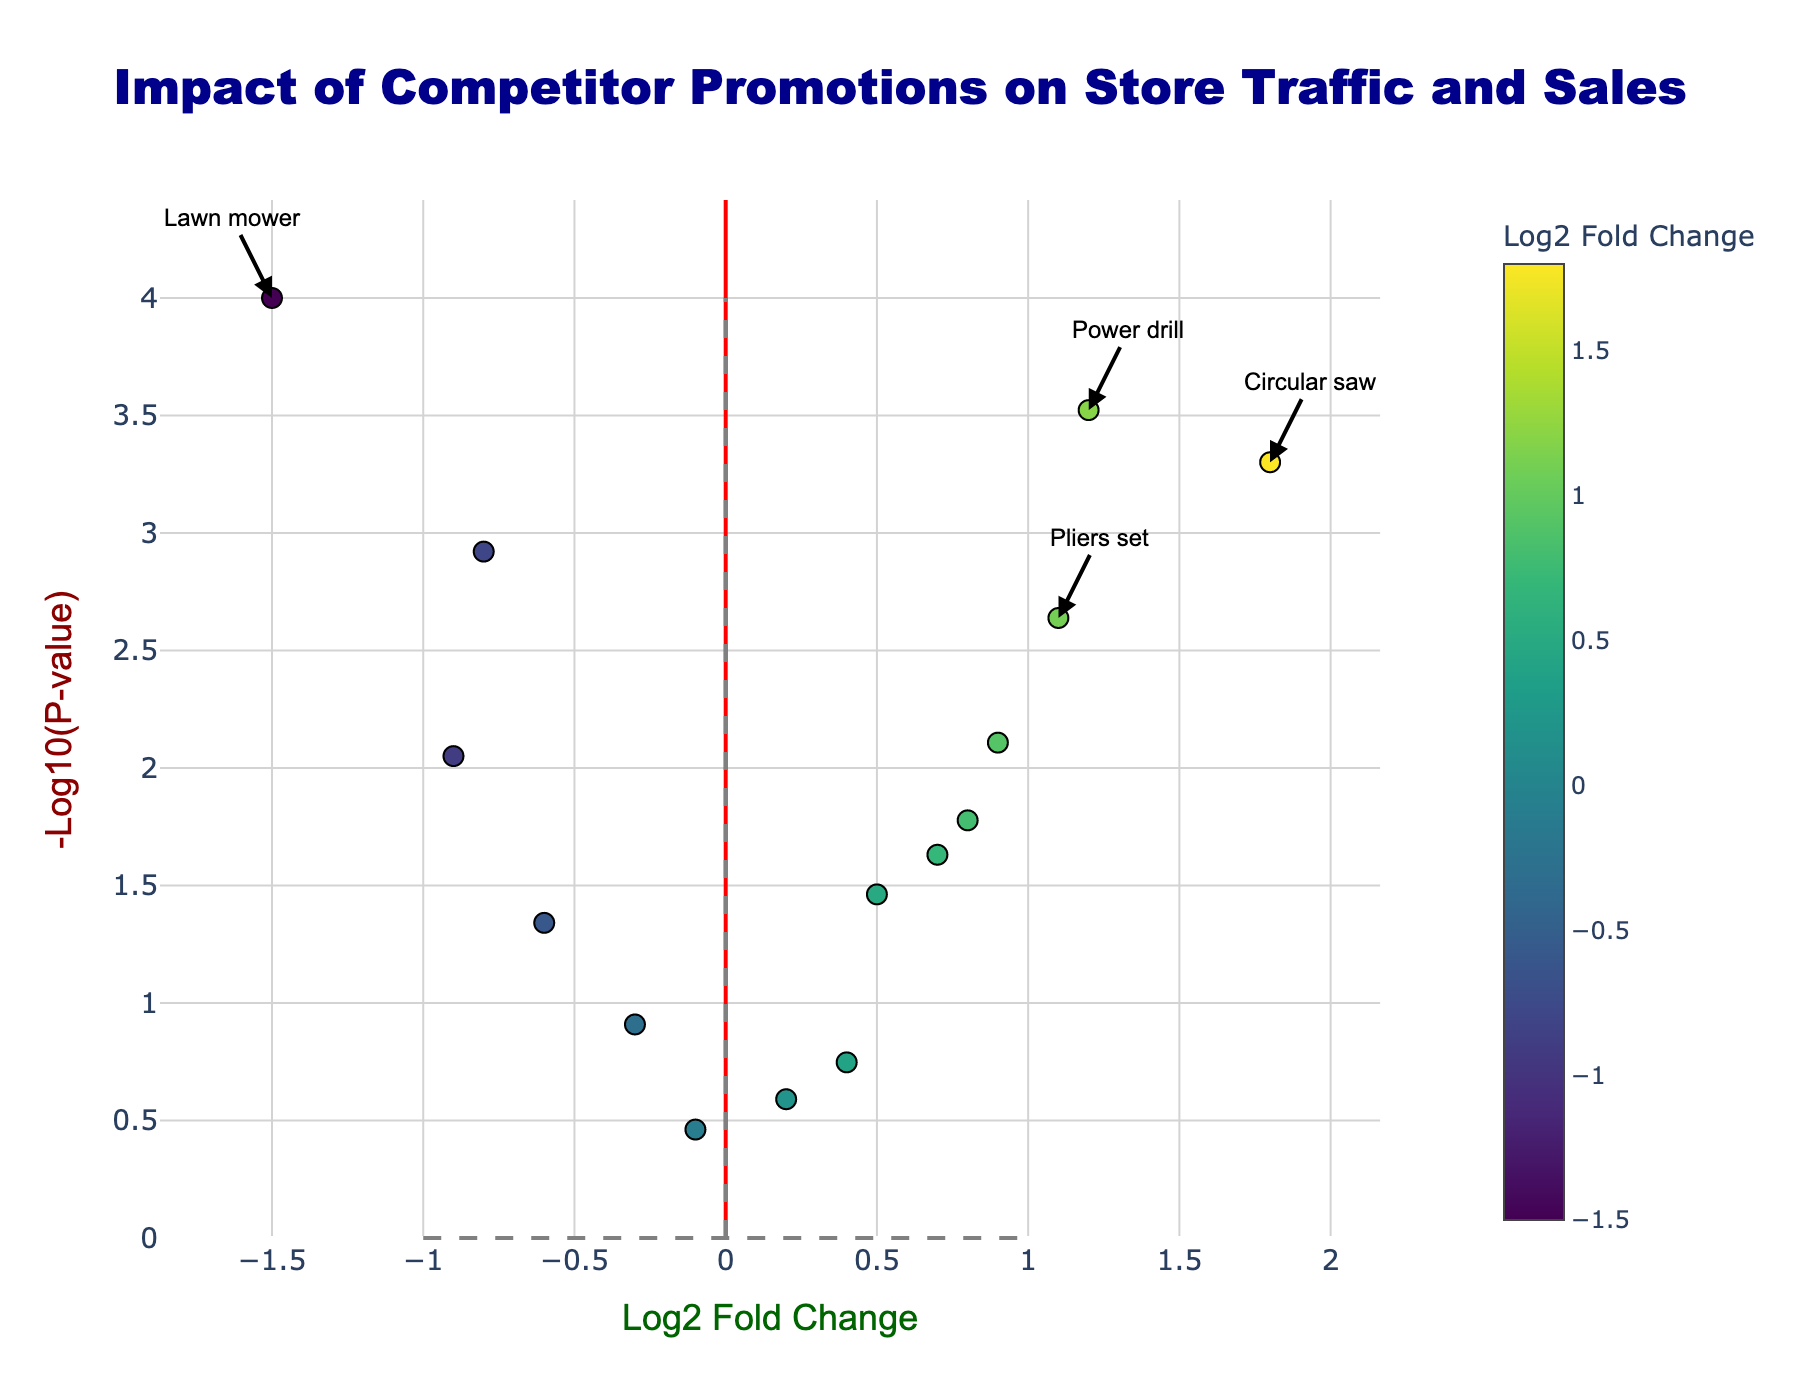What is the title of the plot? Look at the top of the plot where the title is written in large, darkblue font.
Answer: Impact of Competitor Promotions on Store Traffic and Sales What does the x-axis represent? The x-axis is labeled with "Log2 Fold Change", which indicates the title of the axis.
Answer: Log2 Fold Change How many data points are displayed in the plot? Count the number of markers, each representing a product in the plot. There are 14 products listed in the data table.
Answer: 14 Which product has the highest Log2 fold change? Identify the data point with the highest value on the x-axis. The Circular saw has the highest log2 fold change of 1.8.
Answer: Circular saw Which products are considered significant, and why? Locate data points that are annotated and have both high or low log2 fold change (greater than 1 or less than -1) and -log10(p-value) greater than 2.
Answer: Power drill, Circular saw, Lawn mower, Pliers set What color represents positive Log2 fold changes? Check the colors indicated by the colorbar. Positive log2 fold changes (e.g., Circular saw, Power drill) appear in a yellowish color.
Answer: Yellowish What is the p-value threshold for significance in this plot? Refer to the y-axis where the threshold line is drawn at -log10(p-value) = 2, which corresponds to a p-value of 0.01.
Answer: 0.01 Which product has the smallest p-value and what is its Log2 fold change? Identify the product with the highest y-axis value(-log10(p-value)). The lawn mower has a -log10(p-value) of 4, equating to a p-value of 0.0001 and a log2 fold change of -1.5.
Answer: Lawn mower What proportion of products have a negative Log2 fold change? Divide the number of products with a log2 fold change less than 0 (Hammer set, Screwdriver kit, Lawn mower, Ladder, Sanding paper, Work gloves) by the total number (14).
Answer: 6/14 or approximately 43% Which product is closest to zero on the x-axis, and what is its p-value? Find the product nearest to the x-axis value of 0. The Work gloves have the closest log2 fold change to zero at -0.1 with a p-value of 0.3456.
Answer: Work gloves 